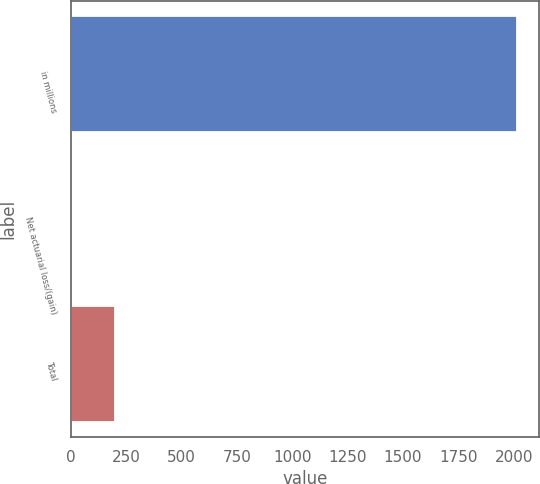<chart> <loc_0><loc_0><loc_500><loc_500><bar_chart><fcel>in millions<fcel>Net actuarial loss/(gain)<fcel>Total<nl><fcel>2013<fcel>0.2<fcel>201.48<nl></chart> 